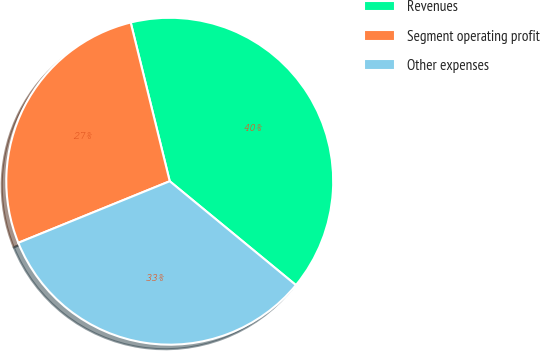Convert chart. <chart><loc_0><loc_0><loc_500><loc_500><pie_chart><fcel>Revenues<fcel>Segment operating profit<fcel>Other expenses<nl><fcel>39.8%<fcel>27.31%<fcel>32.89%<nl></chart> 